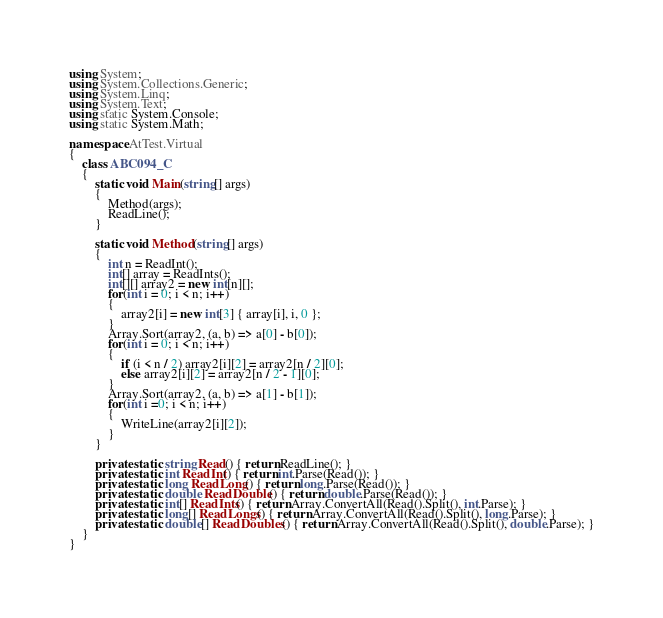<code> <loc_0><loc_0><loc_500><loc_500><_C#_>using System;
using System.Collections.Generic;
using System.Linq;
using System.Text;
using static System.Console;
using static System.Math;

namespace AtTest.Virtual
{
    class ABC094_C
    {
        static void Main(string[] args)
        {
            Method(args);
            ReadLine();
        }

        static void Method(string[] args)
        {
            int n = ReadInt();
            int[] array = ReadInts();
            int[][] array2 = new int[n][];
            for(int i = 0; i < n; i++)
            {
                array2[i] = new int[3] { array[i], i, 0 };
            }
            Array.Sort(array2, (a, b) => a[0] - b[0]);
            for(int i = 0; i < n; i++)
            {
                if (i < n / 2) array2[i][2] = array2[n / 2][0];
                else array2[i][2] = array2[n / 2 - 1][0];
            }
            Array.Sort(array2, (a, b) => a[1] - b[1]);
            for(int i =0; i < n; i++)
            {
                WriteLine(array2[i][2]);
            }
        }

        private static string Read() { return ReadLine(); }
        private static int ReadInt() { return int.Parse(Read()); }
        private static long ReadLong() { return long.Parse(Read()); }
        private static double ReadDouble() { return double.Parse(Read()); }
        private static int[] ReadInts() { return Array.ConvertAll(Read().Split(), int.Parse); }
        private static long[] ReadLongs() { return Array.ConvertAll(Read().Split(), long.Parse); }
        private static double[] ReadDoubles() { return Array.ConvertAll(Read().Split(), double.Parse); }
    }
}
</code> 